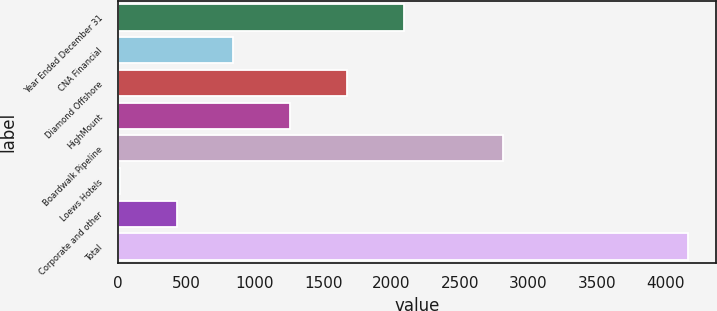Convert chart. <chart><loc_0><loc_0><loc_500><loc_500><bar_chart><fcel>Year Ended December 31<fcel>CNA Financial<fcel>Diamond Offshore<fcel>HighMount<fcel>Boardwalk Pipeline<fcel>Loews Hotels<fcel>Corporate and other<fcel>Total<nl><fcel>2089<fcel>844.6<fcel>1674.2<fcel>1259.4<fcel>2812<fcel>15<fcel>429.8<fcel>4163<nl></chart> 